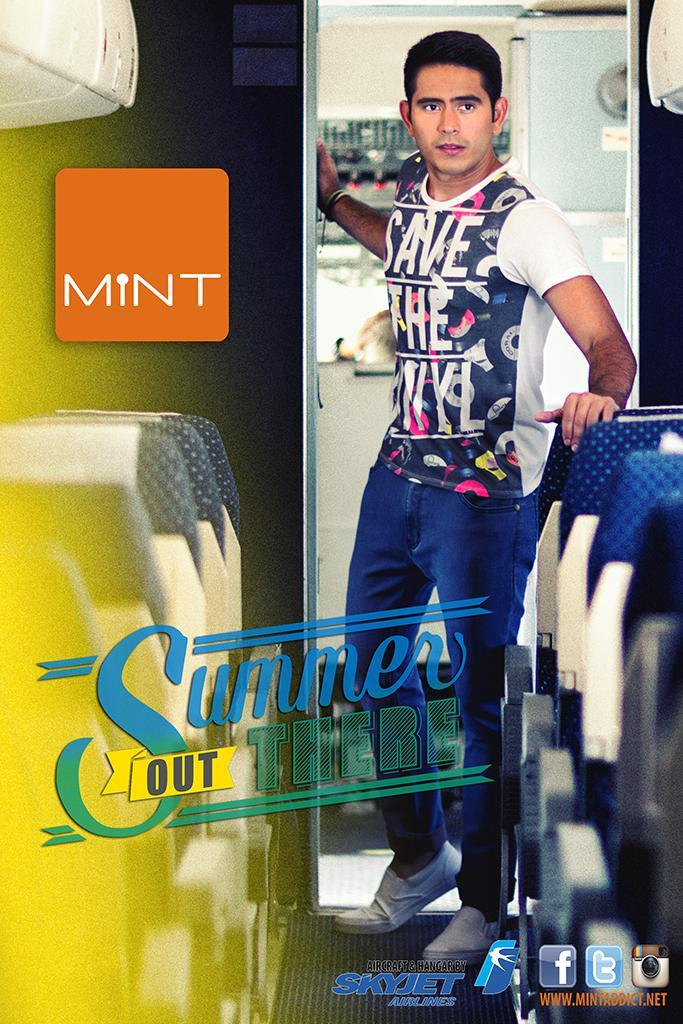<image>
Present a compact description of the photo's key features. a man wearing a shirt with save the on it 